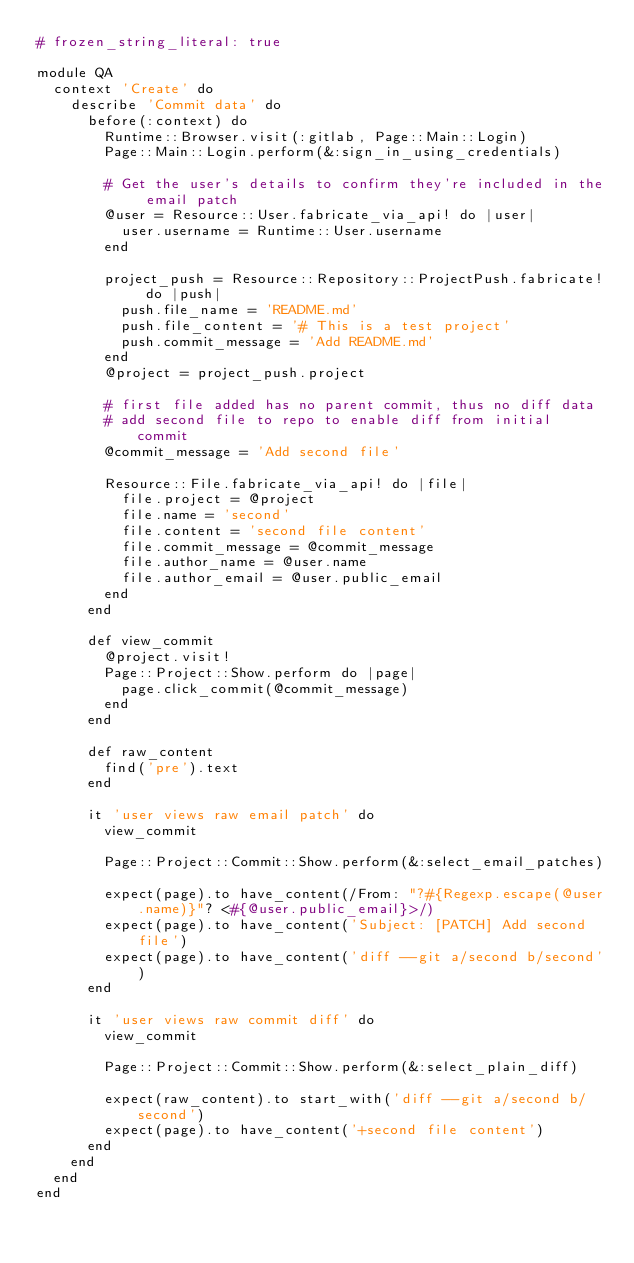<code> <loc_0><loc_0><loc_500><loc_500><_Ruby_># frozen_string_literal: true

module QA
  context 'Create' do
    describe 'Commit data' do
      before(:context) do
        Runtime::Browser.visit(:gitlab, Page::Main::Login)
        Page::Main::Login.perform(&:sign_in_using_credentials)

        # Get the user's details to confirm they're included in the email patch
        @user = Resource::User.fabricate_via_api! do |user|
          user.username = Runtime::User.username
        end

        project_push = Resource::Repository::ProjectPush.fabricate! do |push|
          push.file_name = 'README.md'
          push.file_content = '# This is a test project'
          push.commit_message = 'Add README.md'
        end
        @project = project_push.project

        # first file added has no parent commit, thus no diff data
        # add second file to repo to enable diff from initial commit
        @commit_message = 'Add second file'

        Resource::File.fabricate_via_api! do |file|
          file.project = @project
          file.name = 'second'
          file.content = 'second file content'
          file.commit_message = @commit_message
          file.author_name = @user.name
          file.author_email = @user.public_email
        end
      end

      def view_commit
        @project.visit!
        Page::Project::Show.perform do |page|
          page.click_commit(@commit_message)
        end
      end

      def raw_content
        find('pre').text
      end

      it 'user views raw email patch' do
        view_commit

        Page::Project::Commit::Show.perform(&:select_email_patches)

        expect(page).to have_content(/From: "?#{Regexp.escape(@user.name)}"? <#{@user.public_email}>/)
        expect(page).to have_content('Subject: [PATCH] Add second file')
        expect(page).to have_content('diff --git a/second b/second')
      end

      it 'user views raw commit diff' do
        view_commit

        Page::Project::Commit::Show.perform(&:select_plain_diff)

        expect(raw_content).to start_with('diff --git a/second b/second')
        expect(page).to have_content('+second file content')
      end
    end
  end
end
</code> 